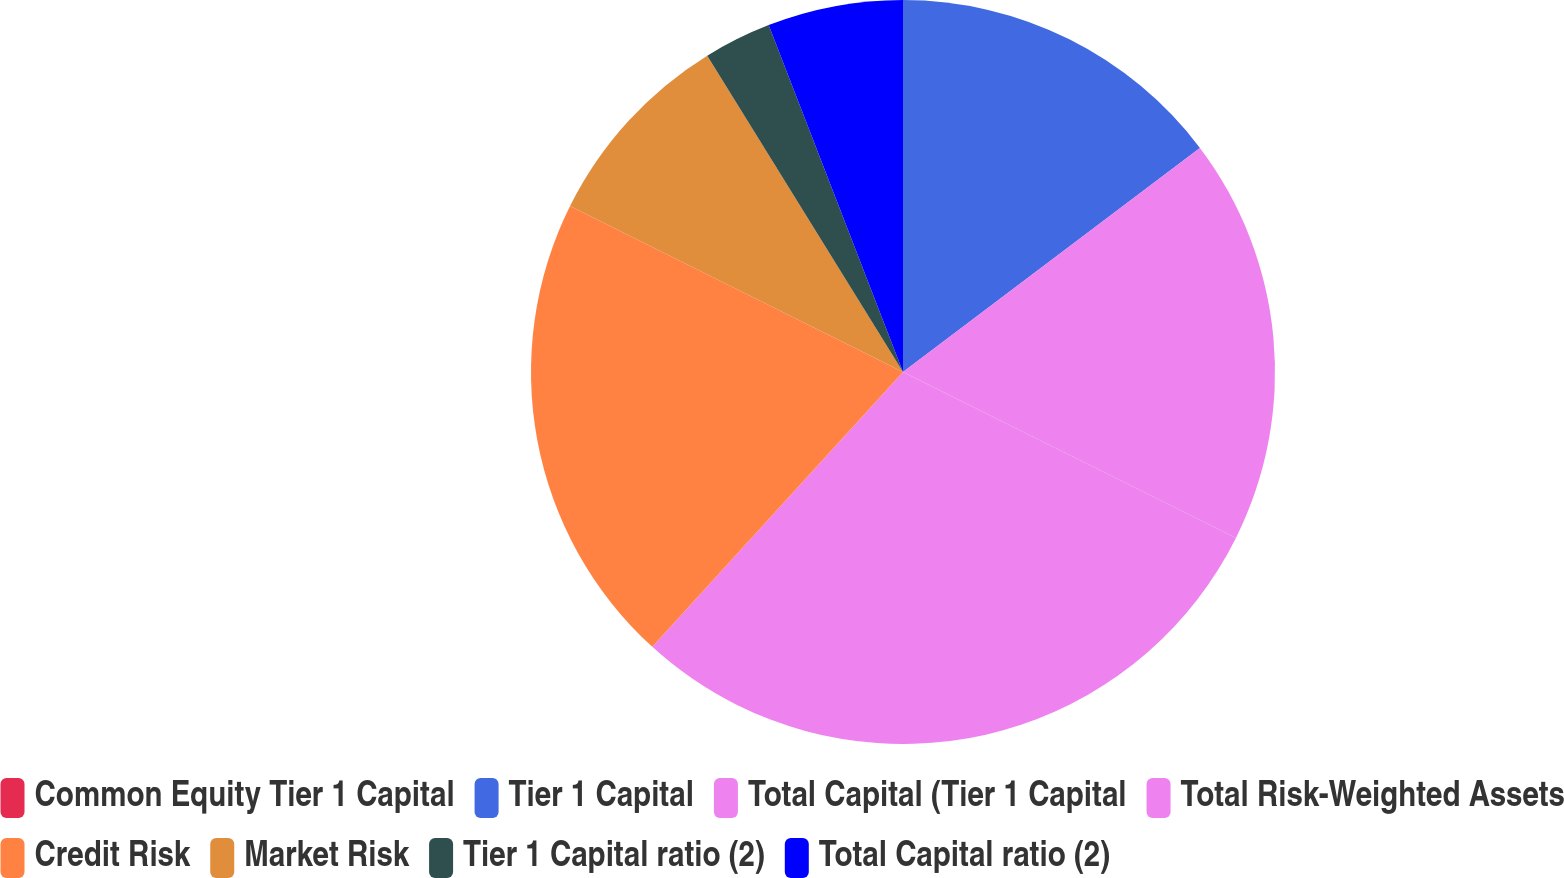Convert chart. <chart><loc_0><loc_0><loc_500><loc_500><pie_chart><fcel>Common Equity Tier 1 Capital<fcel>Tier 1 Capital<fcel>Total Capital (Tier 1 Capital<fcel>Total Risk-Weighted Assets<fcel>Credit Risk<fcel>Market Risk<fcel>Tier 1 Capital ratio (2)<fcel>Total Capital ratio (2)<nl><fcel>0.0%<fcel>14.71%<fcel>17.65%<fcel>29.41%<fcel>20.59%<fcel>8.82%<fcel>2.94%<fcel>5.88%<nl></chart> 